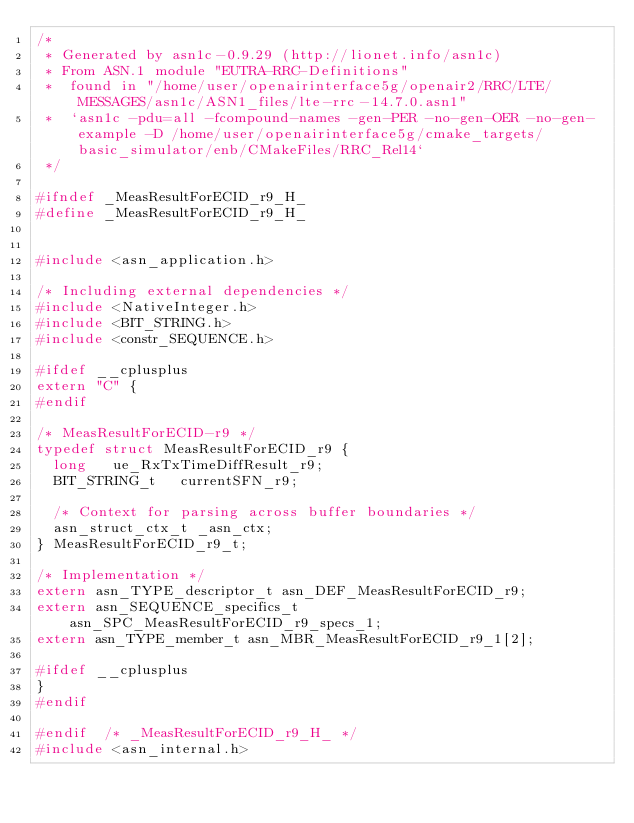Convert code to text. <code><loc_0><loc_0><loc_500><loc_500><_C_>/*
 * Generated by asn1c-0.9.29 (http://lionet.info/asn1c)
 * From ASN.1 module "EUTRA-RRC-Definitions"
 * 	found in "/home/user/openairinterface5g/openair2/RRC/LTE/MESSAGES/asn1c/ASN1_files/lte-rrc-14.7.0.asn1"
 * 	`asn1c -pdu=all -fcompound-names -gen-PER -no-gen-OER -no-gen-example -D /home/user/openairinterface5g/cmake_targets/basic_simulator/enb/CMakeFiles/RRC_Rel14`
 */

#ifndef	_MeasResultForECID_r9_H_
#define	_MeasResultForECID_r9_H_


#include <asn_application.h>

/* Including external dependencies */
#include <NativeInteger.h>
#include <BIT_STRING.h>
#include <constr_SEQUENCE.h>

#ifdef __cplusplus
extern "C" {
#endif

/* MeasResultForECID-r9 */
typedef struct MeasResultForECID_r9 {
	long	 ue_RxTxTimeDiffResult_r9;
	BIT_STRING_t	 currentSFN_r9;
	
	/* Context for parsing across buffer boundaries */
	asn_struct_ctx_t _asn_ctx;
} MeasResultForECID_r9_t;

/* Implementation */
extern asn_TYPE_descriptor_t asn_DEF_MeasResultForECID_r9;
extern asn_SEQUENCE_specifics_t asn_SPC_MeasResultForECID_r9_specs_1;
extern asn_TYPE_member_t asn_MBR_MeasResultForECID_r9_1[2];

#ifdef __cplusplus
}
#endif

#endif	/* _MeasResultForECID_r9_H_ */
#include <asn_internal.h>
</code> 